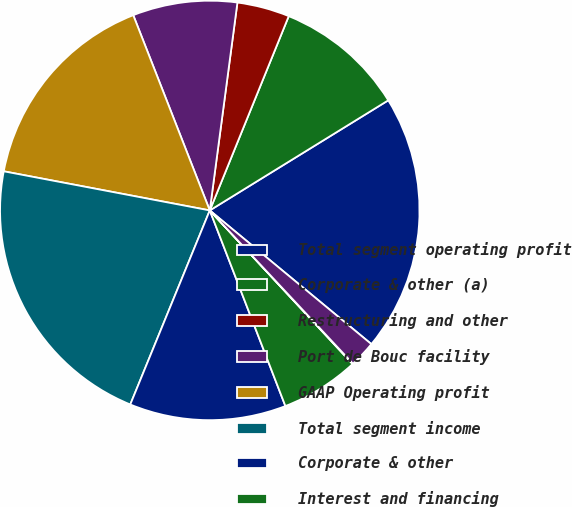Convert chart. <chart><loc_0><loc_0><loc_500><loc_500><pie_chart><fcel>Total segment operating profit<fcel>Corporate & other (a)<fcel>Restructuring and other<fcel>Port de Bouc facility<fcel>GAAP Operating profit<fcel>Total segment income<fcel>Corporate & other<fcel>Interest and financing<fcel>Other (expenses) income net<fcel>Income tax benefit<nl><fcel>19.8%<fcel>10.06%<fcel>4.04%<fcel>8.05%<fcel>16.07%<fcel>21.8%<fcel>12.06%<fcel>6.05%<fcel>0.04%<fcel>2.04%<nl></chart> 